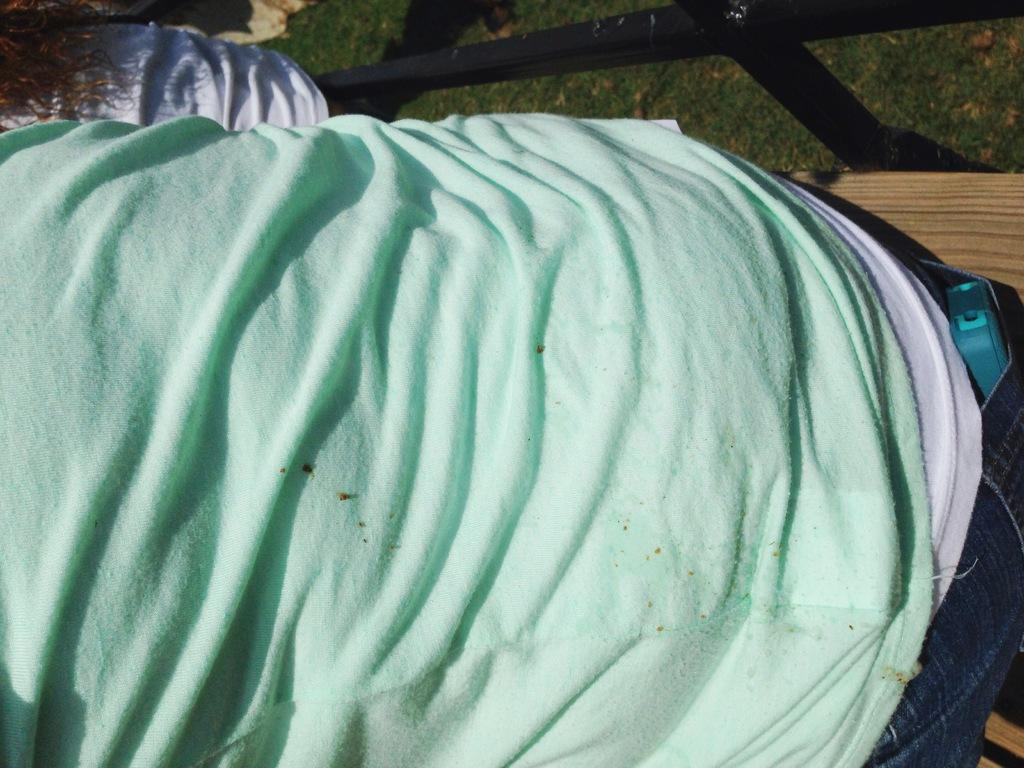How many people are present in the image? There are two persons in the image. What can be seen in the background of the image? There is grass in the background of the image. Where is the lunchroom located in the image? There is no lunchroom present in the image. What type of pet can be seen playing with the persons in the image? There is no pet present in the image. 